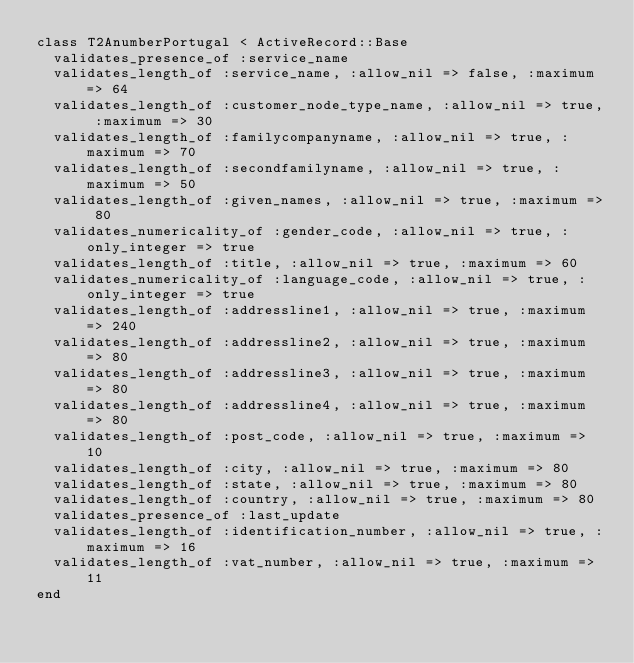Convert code to text. <code><loc_0><loc_0><loc_500><loc_500><_Ruby_>class T2AnumberPortugal < ActiveRecord::Base
  validates_presence_of :service_name
  validates_length_of :service_name, :allow_nil => false, :maximum => 64
  validates_length_of :customer_node_type_name, :allow_nil => true, :maximum => 30
  validates_length_of :familycompanyname, :allow_nil => true, :maximum => 70
  validates_length_of :secondfamilyname, :allow_nil => true, :maximum => 50
  validates_length_of :given_names, :allow_nil => true, :maximum => 80
  validates_numericality_of :gender_code, :allow_nil => true, :only_integer => true
  validates_length_of :title, :allow_nil => true, :maximum => 60
  validates_numericality_of :language_code, :allow_nil => true, :only_integer => true
  validates_length_of :addressline1, :allow_nil => true, :maximum => 240
  validates_length_of :addressline2, :allow_nil => true, :maximum => 80
  validates_length_of :addressline3, :allow_nil => true, :maximum => 80
  validates_length_of :addressline4, :allow_nil => true, :maximum => 80
  validates_length_of :post_code, :allow_nil => true, :maximum => 10
  validates_length_of :city, :allow_nil => true, :maximum => 80
  validates_length_of :state, :allow_nil => true, :maximum => 80
  validates_length_of :country, :allow_nil => true, :maximum => 80
  validates_presence_of :last_update
  validates_length_of :identification_number, :allow_nil => true, :maximum => 16
  validates_length_of :vat_number, :allow_nil => true, :maximum => 11
end
</code> 